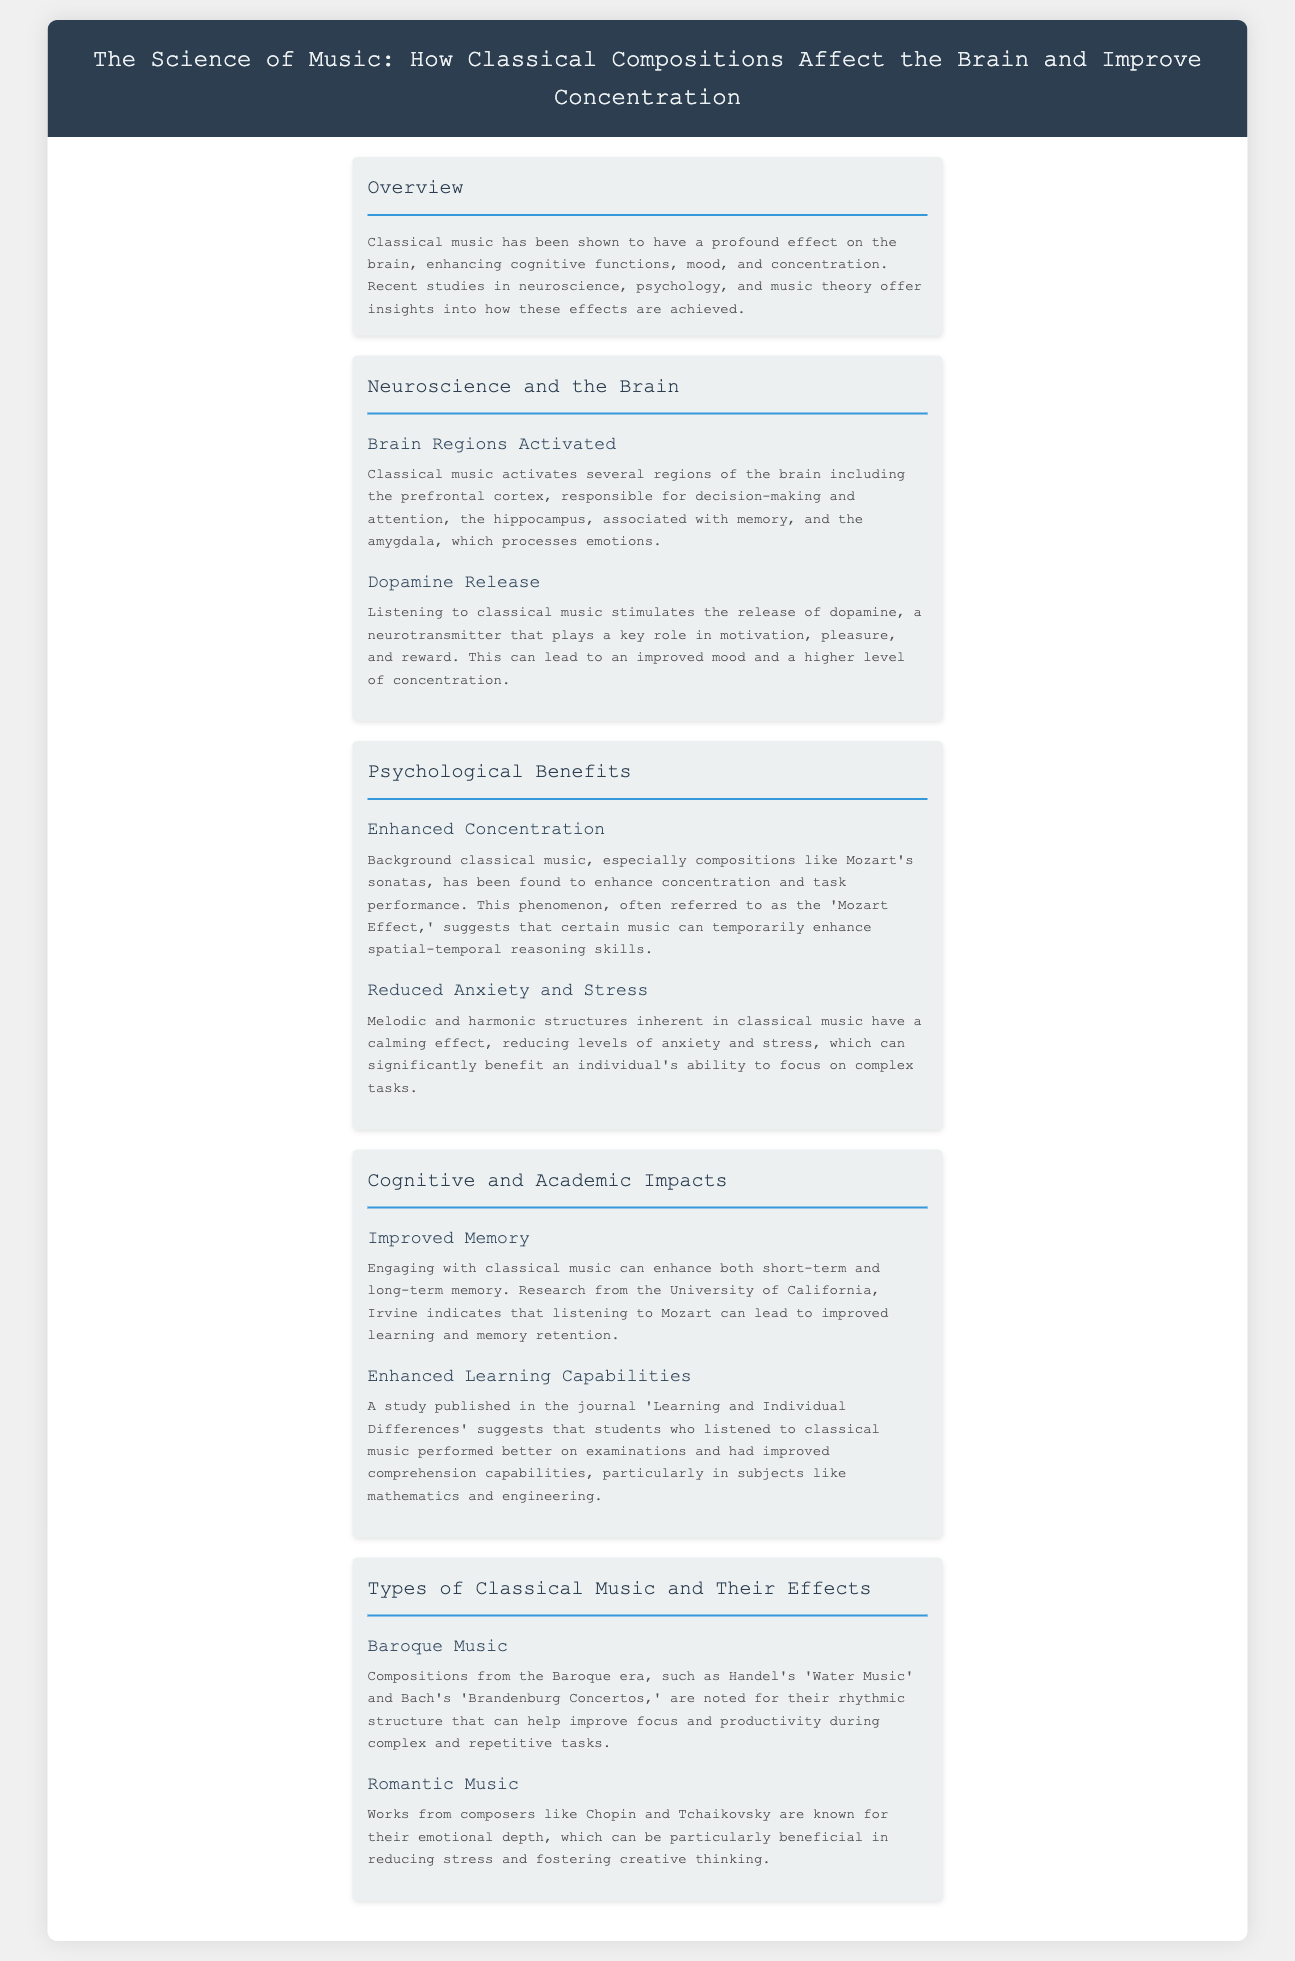What is the main theme of the document? The document discusses how classical music affects the brain and improves concentration.
Answer: The Science of Music Which brain region is responsible for decision-making and attention? The document states that the prefrontal cortex is responsible for decision-making and attention.
Answer: Prefrontal cortex What is the 'Mozart Effect'? The document describes the 'Mozart Effect' as a phenomenon that suggests certain music can enhance concentration and task performance.
Answer: Enhanced concentration What type of music is known for its emotional depth? The document mentions that works from composers like Chopin and Tchaikovsky are known for their emotional depth.
Answer: Romantic Music Which research study is cited regarding improved memory retention? The document refers to research from the University of California, Irvine indicating improved memory retention related to classical music.
Answer: University of California, Irvine How does classical music impact levels of anxiety? The document states that classical music has a calming effect, reducing levels of anxiety.
Answer: Calming effect What are compositions from the Baroque era noted for? The document notes that Baroque music is noted for its rhythmic structure that can help improve focus and productivity.
Answer: Rhythmic structure What are two cognitive benefits of listening to classical music? The document lists improved memory and enhanced learning capabilities as cognitive benefits of listening to classical music.
Answer: Improved memory and enhanced learning capabilities Which neurotransmitter is released when listening to classical music? According to the document, listening to classical music stimulates the release of dopamine.
Answer: Dopamine 